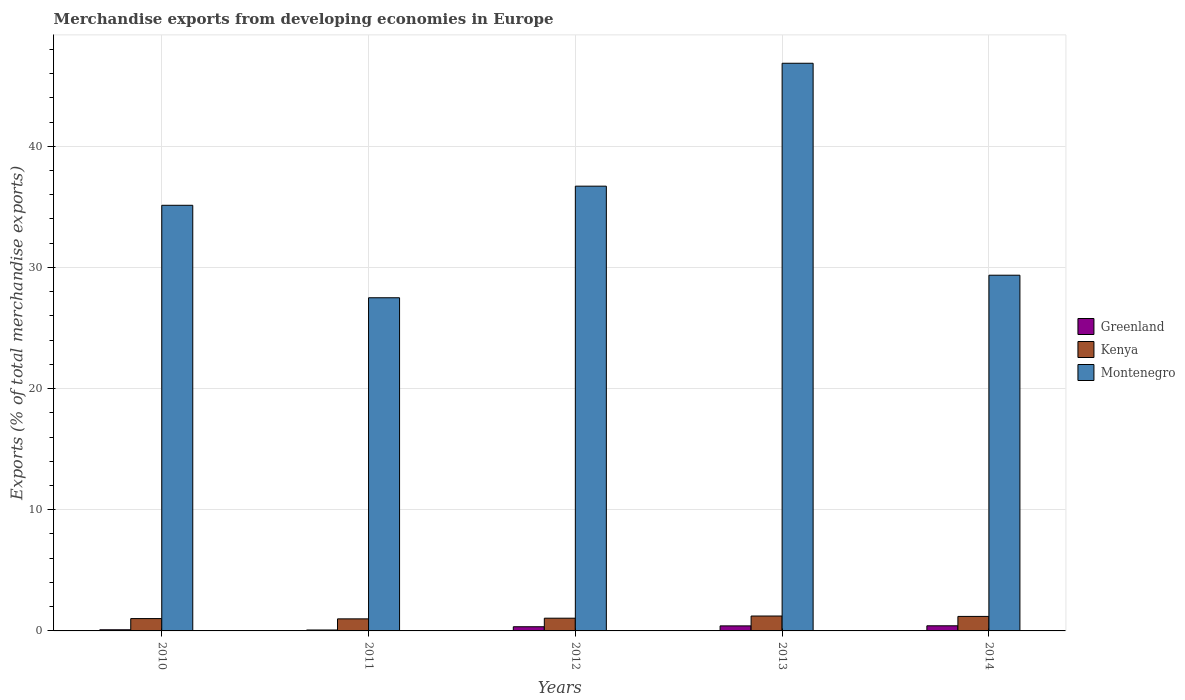How many different coloured bars are there?
Provide a short and direct response. 3. How many groups of bars are there?
Your answer should be very brief. 5. Are the number of bars on each tick of the X-axis equal?
Give a very brief answer. Yes. What is the percentage of total merchandise exports in Greenland in 2014?
Ensure brevity in your answer.  0.42. Across all years, what is the maximum percentage of total merchandise exports in Montenegro?
Offer a terse response. 46.85. Across all years, what is the minimum percentage of total merchandise exports in Montenegro?
Your answer should be compact. 27.5. In which year was the percentage of total merchandise exports in Kenya maximum?
Provide a succinct answer. 2013. What is the total percentage of total merchandise exports in Montenegro in the graph?
Offer a very short reply. 175.54. What is the difference between the percentage of total merchandise exports in Greenland in 2013 and that in 2014?
Make the answer very short. -0.01. What is the difference between the percentage of total merchandise exports in Montenegro in 2014 and the percentage of total merchandise exports in Greenland in 2012?
Make the answer very short. 29.01. What is the average percentage of total merchandise exports in Montenegro per year?
Ensure brevity in your answer.  35.11. In the year 2010, what is the difference between the percentage of total merchandise exports in Montenegro and percentage of total merchandise exports in Kenya?
Give a very brief answer. 34.11. In how many years, is the percentage of total merchandise exports in Greenland greater than 26 %?
Give a very brief answer. 0. What is the ratio of the percentage of total merchandise exports in Kenya in 2012 to that in 2014?
Provide a short and direct response. 0.88. Is the difference between the percentage of total merchandise exports in Montenegro in 2010 and 2012 greater than the difference between the percentage of total merchandise exports in Kenya in 2010 and 2012?
Offer a terse response. No. What is the difference between the highest and the second highest percentage of total merchandise exports in Greenland?
Provide a short and direct response. 0.01. What is the difference between the highest and the lowest percentage of total merchandise exports in Kenya?
Your answer should be very brief. 0.23. What does the 3rd bar from the left in 2014 represents?
Provide a short and direct response. Montenegro. What does the 3rd bar from the right in 2012 represents?
Keep it short and to the point. Greenland. Are all the bars in the graph horizontal?
Ensure brevity in your answer.  No. How many years are there in the graph?
Your answer should be compact. 5. Does the graph contain any zero values?
Make the answer very short. No. Where does the legend appear in the graph?
Give a very brief answer. Center right. What is the title of the graph?
Keep it short and to the point. Merchandise exports from developing economies in Europe. Does "Norway" appear as one of the legend labels in the graph?
Your answer should be very brief. No. What is the label or title of the X-axis?
Give a very brief answer. Years. What is the label or title of the Y-axis?
Keep it short and to the point. Exports (% of total merchandise exports). What is the Exports (% of total merchandise exports) of Greenland in 2010?
Make the answer very short. 0.1. What is the Exports (% of total merchandise exports) in Kenya in 2010?
Provide a succinct answer. 1.02. What is the Exports (% of total merchandise exports) in Montenegro in 2010?
Your answer should be very brief. 35.13. What is the Exports (% of total merchandise exports) of Greenland in 2011?
Ensure brevity in your answer.  0.08. What is the Exports (% of total merchandise exports) of Kenya in 2011?
Give a very brief answer. 1. What is the Exports (% of total merchandise exports) in Montenegro in 2011?
Your response must be concise. 27.5. What is the Exports (% of total merchandise exports) in Greenland in 2012?
Provide a short and direct response. 0.34. What is the Exports (% of total merchandise exports) in Kenya in 2012?
Offer a terse response. 1.05. What is the Exports (% of total merchandise exports) in Montenegro in 2012?
Offer a very short reply. 36.71. What is the Exports (% of total merchandise exports) in Greenland in 2013?
Provide a succinct answer. 0.42. What is the Exports (% of total merchandise exports) of Kenya in 2013?
Keep it short and to the point. 1.23. What is the Exports (% of total merchandise exports) in Montenegro in 2013?
Provide a succinct answer. 46.85. What is the Exports (% of total merchandise exports) of Greenland in 2014?
Give a very brief answer. 0.42. What is the Exports (% of total merchandise exports) of Kenya in 2014?
Your answer should be compact. 1.2. What is the Exports (% of total merchandise exports) in Montenegro in 2014?
Your response must be concise. 29.36. Across all years, what is the maximum Exports (% of total merchandise exports) of Greenland?
Offer a very short reply. 0.42. Across all years, what is the maximum Exports (% of total merchandise exports) of Kenya?
Offer a terse response. 1.23. Across all years, what is the maximum Exports (% of total merchandise exports) of Montenegro?
Your answer should be very brief. 46.85. Across all years, what is the minimum Exports (% of total merchandise exports) in Greenland?
Your answer should be compact. 0.08. Across all years, what is the minimum Exports (% of total merchandise exports) of Kenya?
Make the answer very short. 1. Across all years, what is the minimum Exports (% of total merchandise exports) in Montenegro?
Offer a very short reply. 27.5. What is the total Exports (% of total merchandise exports) of Greenland in the graph?
Provide a succinct answer. 1.35. What is the total Exports (% of total merchandise exports) of Kenya in the graph?
Offer a very short reply. 5.49. What is the total Exports (% of total merchandise exports) of Montenegro in the graph?
Give a very brief answer. 175.54. What is the difference between the Exports (% of total merchandise exports) in Greenland in 2010 and that in 2011?
Make the answer very short. 0.02. What is the difference between the Exports (% of total merchandise exports) in Kenya in 2010 and that in 2011?
Offer a very short reply. 0.02. What is the difference between the Exports (% of total merchandise exports) of Montenegro in 2010 and that in 2011?
Offer a terse response. 7.63. What is the difference between the Exports (% of total merchandise exports) of Greenland in 2010 and that in 2012?
Offer a very short reply. -0.25. What is the difference between the Exports (% of total merchandise exports) of Kenya in 2010 and that in 2012?
Offer a terse response. -0.03. What is the difference between the Exports (% of total merchandise exports) of Montenegro in 2010 and that in 2012?
Your response must be concise. -1.58. What is the difference between the Exports (% of total merchandise exports) in Greenland in 2010 and that in 2013?
Keep it short and to the point. -0.32. What is the difference between the Exports (% of total merchandise exports) in Kenya in 2010 and that in 2013?
Your answer should be compact. -0.21. What is the difference between the Exports (% of total merchandise exports) in Montenegro in 2010 and that in 2013?
Offer a very short reply. -11.72. What is the difference between the Exports (% of total merchandise exports) in Greenland in 2010 and that in 2014?
Your answer should be compact. -0.33. What is the difference between the Exports (% of total merchandise exports) in Kenya in 2010 and that in 2014?
Ensure brevity in your answer.  -0.18. What is the difference between the Exports (% of total merchandise exports) of Montenegro in 2010 and that in 2014?
Ensure brevity in your answer.  5.77. What is the difference between the Exports (% of total merchandise exports) in Greenland in 2011 and that in 2012?
Offer a very short reply. -0.27. What is the difference between the Exports (% of total merchandise exports) of Kenya in 2011 and that in 2012?
Your answer should be compact. -0.06. What is the difference between the Exports (% of total merchandise exports) of Montenegro in 2011 and that in 2012?
Make the answer very short. -9.21. What is the difference between the Exports (% of total merchandise exports) of Greenland in 2011 and that in 2013?
Offer a terse response. -0.34. What is the difference between the Exports (% of total merchandise exports) in Kenya in 2011 and that in 2013?
Give a very brief answer. -0.23. What is the difference between the Exports (% of total merchandise exports) in Montenegro in 2011 and that in 2013?
Keep it short and to the point. -19.35. What is the difference between the Exports (% of total merchandise exports) of Greenland in 2011 and that in 2014?
Ensure brevity in your answer.  -0.35. What is the difference between the Exports (% of total merchandise exports) of Kenya in 2011 and that in 2014?
Offer a terse response. -0.2. What is the difference between the Exports (% of total merchandise exports) of Montenegro in 2011 and that in 2014?
Your response must be concise. -1.86. What is the difference between the Exports (% of total merchandise exports) of Greenland in 2012 and that in 2013?
Make the answer very short. -0.07. What is the difference between the Exports (% of total merchandise exports) of Kenya in 2012 and that in 2013?
Your answer should be compact. -0.18. What is the difference between the Exports (% of total merchandise exports) of Montenegro in 2012 and that in 2013?
Your answer should be very brief. -10.14. What is the difference between the Exports (% of total merchandise exports) of Greenland in 2012 and that in 2014?
Provide a short and direct response. -0.08. What is the difference between the Exports (% of total merchandise exports) of Kenya in 2012 and that in 2014?
Keep it short and to the point. -0.15. What is the difference between the Exports (% of total merchandise exports) of Montenegro in 2012 and that in 2014?
Provide a succinct answer. 7.35. What is the difference between the Exports (% of total merchandise exports) of Greenland in 2013 and that in 2014?
Keep it short and to the point. -0.01. What is the difference between the Exports (% of total merchandise exports) in Kenya in 2013 and that in 2014?
Provide a short and direct response. 0.03. What is the difference between the Exports (% of total merchandise exports) in Montenegro in 2013 and that in 2014?
Ensure brevity in your answer.  17.49. What is the difference between the Exports (% of total merchandise exports) of Greenland in 2010 and the Exports (% of total merchandise exports) of Kenya in 2011?
Offer a very short reply. -0.9. What is the difference between the Exports (% of total merchandise exports) of Greenland in 2010 and the Exports (% of total merchandise exports) of Montenegro in 2011?
Give a very brief answer. -27.4. What is the difference between the Exports (% of total merchandise exports) of Kenya in 2010 and the Exports (% of total merchandise exports) of Montenegro in 2011?
Provide a succinct answer. -26.48. What is the difference between the Exports (% of total merchandise exports) in Greenland in 2010 and the Exports (% of total merchandise exports) in Kenya in 2012?
Give a very brief answer. -0.96. What is the difference between the Exports (% of total merchandise exports) of Greenland in 2010 and the Exports (% of total merchandise exports) of Montenegro in 2012?
Offer a very short reply. -36.61. What is the difference between the Exports (% of total merchandise exports) of Kenya in 2010 and the Exports (% of total merchandise exports) of Montenegro in 2012?
Offer a terse response. -35.69. What is the difference between the Exports (% of total merchandise exports) of Greenland in 2010 and the Exports (% of total merchandise exports) of Kenya in 2013?
Make the answer very short. -1.13. What is the difference between the Exports (% of total merchandise exports) in Greenland in 2010 and the Exports (% of total merchandise exports) in Montenegro in 2013?
Give a very brief answer. -46.76. What is the difference between the Exports (% of total merchandise exports) of Kenya in 2010 and the Exports (% of total merchandise exports) of Montenegro in 2013?
Offer a very short reply. -45.83. What is the difference between the Exports (% of total merchandise exports) of Greenland in 2010 and the Exports (% of total merchandise exports) of Kenya in 2014?
Ensure brevity in your answer.  -1.1. What is the difference between the Exports (% of total merchandise exports) of Greenland in 2010 and the Exports (% of total merchandise exports) of Montenegro in 2014?
Provide a succinct answer. -29.26. What is the difference between the Exports (% of total merchandise exports) in Kenya in 2010 and the Exports (% of total merchandise exports) in Montenegro in 2014?
Offer a very short reply. -28.34. What is the difference between the Exports (% of total merchandise exports) of Greenland in 2011 and the Exports (% of total merchandise exports) of Kenya in 2012?
Ensure brevity in your answer.  -0.97. What is the difference between the Exports (% of total merchandise exports) in Greenland in 2011 and the Exports (% of total merchandise exports) in Montenegro in 2012?
Ensure brevity in your answer.  -36.63. What is the difference between the Exports (% of total merchandise exports) of Kenya in 2011 and the Exports (% of total merchandise exports) of Montenegro in 2012?
Your answer should be compact. -35.71. What is the difference between the Exports (% of total merchandise exports) of Greenland in 2011 and the Exports (% of total merchandise exports) of Kenya in 2013?
Keep it short and to the point. -1.15. What is the difference between the Exports (% of total merchandise exports) in Greenland in 2011 and the Exports (% of total merchandise exports) in Montenegro in 2013?
Provide a succinct answer. -46.78. What is the difference between the Exports (% of total merchandise exports) in Kenya in 2011 and the Exports (% of total merchandise exports) in Montenegro in 2013?
Offer a terse response. -45.86. What is the difference between the Exports (% of total merchandise exports) of Greenland in 2011 and the Exports (% of total merchandise exports) of Kenya in 2014?
Your answer should be compact. -1.12. What is the difference between the Exports (% of total merchandise exports) in Greenland in 2011 and the Exports (% of total merchandise exports) in Montenegro in 2014?
Your response must be concise. -29.28. What is the difference between the Exports (% of total merchandise exports) of Kenya in 2011 and the Exports (% of total merchandise exports) of Montenegro in 2014?
Ensure brevity in your answer.  -28.36. What is the difference between the Exports (% of total merchandise exports) in Greenland in 2012 and the Exports (% of total merchandise exports) in Kenya in 2013?
Provide a succinct answer. -0.88. What is the difference between the Exports (% of total merchandise exports) of Greenland in 2012 and the Exports (% of total merchandise exports) of Montenegro in 2013?
Offer a very short reply. -46.51. What is the difference between the Exports (% of total merchandise exports) of Kenya in 2012 and the Exports (% of total merchandise exports) of Montenegro in 2013?
Provide a succinct answer. -45.8. What is the difference between the Exports (% of total merchandise exports) in Greenland in 2012 and the Exports (% of total merchandise exports) in Kenya in 2014?
Keep it short and to the point. -0.85. What is the difference between the Exports (% of total merchandise exports) in Greenland in 2012 and the Exports (% of total merchandise exports) in Montenegro in 2014?
Offer a terse response. -29.01. What is the difference between the Exports (% of total merchandise exports) in Kenya in 2012 and the Exports (% of total merchandise exports) in Montenegro in 2014?
Keep it short and to the point. -28.31. What is the difference between the Exports (% of total merchandise exports) in Greenland in 2013 and the Exports (% of total merchandise exports) in Kenya in 2014?
Give a very brief answer. -0.78. What is the difference between the Exports (% of total merchandise exports) in Greenland in 2013 and the Exports (% of total merchandise exports) in Montenegro in 2014?
Keep it short and to the point. -28.94. What is the difference between the Exports (% of total merchandise exports) of Kenya in 2013 and the Exports (% of total merchandise exports) of Montenegro in 2014?
Your answer should be compact. -28.13. What is the average Exports (% of total merchandise exports) in Greenland per year?
Your answer should be compact. 0.27. What is the average Exports (% of total merchandise exports) of Kenya per year?
Your answer should be very brief. 1.1. What is the average Exports (% of total merchandise exports) in Montenegro per year?
Keep it short and to the point. 35.11. In the year 2010, what is the difference between the Exports (% of total merchandise exports) in Greenland and Exports (% of total merchandise exports) in Kenya?
Give a very brief answer. -0.92. In the year 2010, what is the difference between the Exports (% of total merchandise exports) of Greenland and Exports (% of total merchandise exports) of Montenegro?
Ensure brevity in your answer.  -35.03. In the year 2010, what is the difference between the Exports (% of total merchandise exports) of Kenya and Exports (% of total merchandise exports) of Montenegro?
Give a very brief answer. -34.11. In the year 2011, what is the difference between the Exports (% of total merchandise exports) in Greenland and Exports (% of total merchandise exports) in Kenya?
Give a very brief answer. -0.92. In the year 2011, what is the difference between the Exports (% of total merchandise exports) in Greenland and Exports (% of total merchandise exports) in Montenegro?
Provide a short and direct response. -27.42. In the year 2011, what is the difference between the Exports (% of total merchandise exports) in Kenya and Exports (% of total merchandise exports) in Montenegro?
Provide a short and direct response. -26.5. In the year 2012, what is the difference between the Exports (% of total merchandise exports) in Greenland and Exports (% of total merchandise exports) in Kenya?
Provide a succinct answer. -0.71. In the year 2012, what is the difference between the Exports (% of total merchandise exports) of Greenland and Exports (% of total merchandise exports) of Montenegro?
Make the answer very short. -36.36. In the year 2012, what is the difference between the Exports (% of total merchandise exports) in Kenya and Exports (% of total merchandise exports) in Montenegro?
Offer a very short reply. -35.66. In the year 2013, what is the difference between the Exports (% of total merchandise exports) in Greenland and Exports (% of total merchandise exports) in Kenya?
Offer a very short reply. -0.81. In the year 2013, what is the difference between the Exports (% of total merchandise exports) of Greenland and Exports (% of total merchandise exports) of Montenegro?
Provide a succinct answer. -46.44. In the year 2013, what is the difference between the Exports (% of total merchandise exports) in Kenya and Exports (% of total merchandise exports) in Montenegro?
Your response must be concise. -45.62. In the year 2014, what is the difference between the Exports (% of total merchandise exports) of Greenland and Exports (% of total merchandise exports) of Kenya?
Your answer should be compact. -0.77. In the year 2014, what is the difference between the Exports (% of total merchandise exports) of Greenland and Exports (% of total merchandise exports) of Montenegro?
Provide a short and direct response. -28.93. In the year 2014, what is the difference between the Exports (% of total merchandise exports) in Kenya and Exports (% of total merchandise exports) in Montenegro?
Ensure brevity in your answer.  -28.16. What is the ratio of the Exports (% of total merchandise exports) in Greenland in 2010 to that in 2011?
Make the answer very short. 1.25. What is the ratio of the Exports (% of total merchandise exports) in Kenya in 2010 to that in 2011?
Give a very brief answer. 1.02. What is the ratio of the Exports (% of total merchandise exports) in Montenegro in 2010 to that in 2011?
Your answer should be compact. 1.28. What is the ratio of the Exports (% of total merchandise exports) in Greenland in 2010 to that in 2012?
Your answer should be compact. 0.28. What is the ratio of the Exports (% of total merchandise exports) of Kenya in 2010 to that in 2012?
Give a very brief answer. 0.97. What is the ratio of the Exports (% of total merchandise exports) of Montenegro in 2010 to that in 2012?
Your answer should be very brief. 0.96. What is the ratio of the Exports (% of total merchandise exports) in Greenland in 2010 to that in 2013?
Make the answer very short. 0.23. What is the ratio of the Exports (% of total merchandise exports) in Kenya in 2010 to that in 2013?
Offer a very short reply. 0.83. What is the ratio of the Exports (% of total merchandise exports) in Montenegro in 2010 to that in 2013?
Provide a succinct answer. 0.75. What is the ratio of the Exports (% of total merchandise exports) in Greenland in 2010 to that in 2014?
Give a very brief answer. 0.22. What is the ratio of the Exports (% of total merchandise exports) in Kenya in 2010 to that in 2014?
Your answer should be compact. 0.85. What is the ratio of the Exports (% of total merchandise exports) of Montenegro in 2010 to that in 2014?
Offer a terse response. 1.2. What is the ratio of the Exports (% of total merchandise exports) in Greenland in 2011 to that in 2012?
Give a very brief answer. 0.22. What is the ratio of the Exports (% of total merchandise exports) of Kenya in 2011 to that in 2012?
Provide a succinct answer. 0.95. What is the ratio of the Exports (% of total merchandise exports) in Montenegro in 2011 to that in 2012?
Make the answer very short. 0.75. What is the ratio of the Exports (% of total merchandise exports) in Greenland in 2011 to that in 2013?
Give a very brief answer. 0.18. What is the ratio of the Exports (% of total merchandise exports) in Kenya in 2011 to that in 2013?
Make the answer very short. 0.81. What is the ratio of the Exports (% of total merchandise exports) in Montenegro in 2011 to that in 2013?
Give a very brief answer. 0.59. What is the ratio of the Exports (% of total merchandise exports) in Greenland in 2011 to that in 2014?
Provide a short and direct response. 0.18. What is the ratio of the Exports (% of total merchandise exports) in Kenya in 2011 to that in 2014?
Provide a succinct answer. 0.83. What is the ratio of the Exports (% of total merchandise exports) of Montenegro in 2011 to that in 2014?
Provide a short and direct response. 0.94. What is the ratio of the Exports (% of total merchandise exports) in Greenland in 2012 to that in 2013?
Offer a terse response. 0.83. What is the ratio of the Exports (% of total merchandise exports) of Kenya in 2012 to that in 2013?
Your response must be concise. 0.85. What is the ratio of the Exports (% of total merchandise exports) of Montenegro in 2012 to that in 2013?
Your answer should be compact. 0.78. What is the ratio of the Exports (% of total merchandise exports) in Greenland in 2012 to that in 2014?
Provide a succinct answer. 0.81. What is the ratio of the Exports (% of total merchandise exports) of Kenya in 2012 to that in 2014?
Your response must be concise. 0.88. What is the ratio of the Exports (% of total merchandise exports) of Montenegro in 2012 to that in 2014?
Ensure brevity in your answer.  1.25. What is the ratio of the Exports (% of total merchandise exports) of Greenland in 2013 to that in 2014?
Offer a terse response. 0.98. What is the ratio of the Exports (% of total merchandise exports) of Kenya in 2013 to that in 2014?
Make the answer very short. 1.03. What is the ratio of the Exports (% of total merchandise exports) in Montenegro in 2013 to that in 2014?
Provide a short and direct response. 1.6. What is the difference between the highest and the second highest Exports (% of total merchandise exports) of Greenland?
Offer a terse response. 0.01. What is the difference between the highest and the second highest Exports (% of total merchandise exports) of Kenya?
Ensure brevity in your answer.  0.03. What is the difference between the highest and the second highest Exports (% of total merchandise exports) in Montenegro?
Offer a very short reply. 10.14. What is the difference between the highest and the lowest Exports (% of total merchandise exports) in Greenland?
Your response must be concise. 0.35. What is the difference between the highest and the lowest Exports (% of total merchandise exports) of Kenya?
Your response must be concise. 0.23. What is the difference between the highest and the lowest Exports (% of total merchandise exports) of Montenegro?
Your answer should be compact. 19.35. 